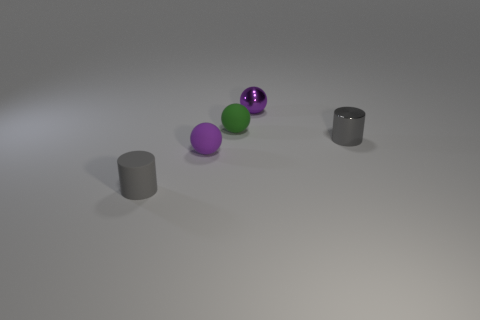What number of purple rubber objects are the same shape as the green matte thing?
Your answer should be very brief. 1. How big is the gray object that is behind the cylinder that is to the left of the small purple matte ball?
Offer a terse response. Small. Does the metallic object that is behind the green sphere have the same color as the small matte sphere left of the green rubber object?
Ensure brevity in your answer.  Yes. There is a tiny gray cylinder right of the gray cylinder that is to the left of the tiny green ball; what number of small gray cylinders are on the left side of it?
Your answer should be very brief. 1. How many small objects are in front of the tiny green thing and to the left of the small purple metallic thing?
Your answer should be compact. 2. Is the number of spheres behind the small gray metallic object greater than the number of gray rubber objects?
Keep it short and to the point. Yes. What number of purple metal things have the same size as the shiny cylinder?
Keep it short and to the point. 1. What size is the other cylinder that is the same color as the tiny metallic cylinder?
Provide a succinct answer. Small. What number of small things are either purple rubber objects or matte cylinders?
Provide a succinct answer. 2. How many small purple shiny spheres are there?
Your answer should be very brief. 1. 